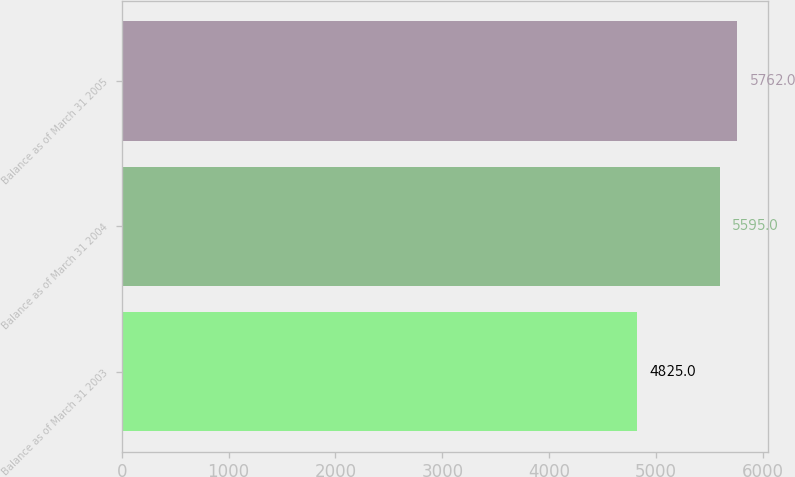<chart> <loc_0><loc_0><loc_500><loc_500><bar_chart><fcel>Balance as of March 31 2003<fcel>Balance as of March 31 2004<fcel>Balance as of March 31 2005<nl><fcel>4825<fcel>5595<fcel>5762<nl></chart> 